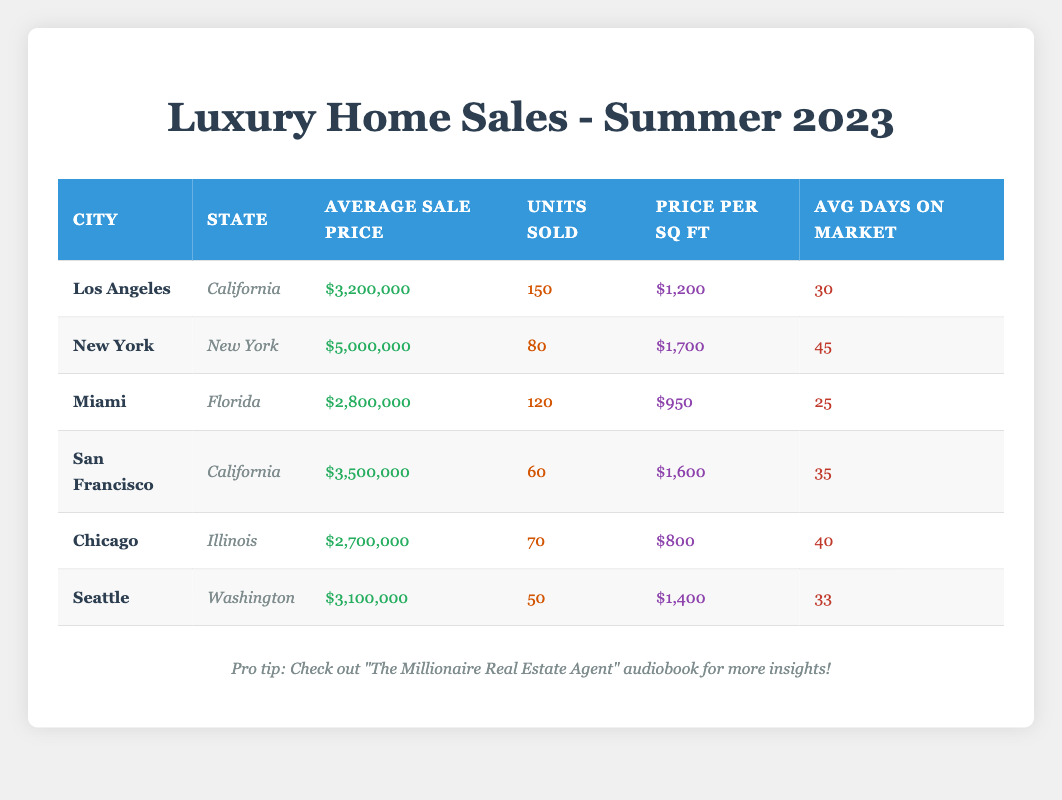What is the average sale price of luxury homes in Miami? The average sale price for luxury homes in Miami is listed in the table as $2,800,000.
Answer: $2,800,000 Which city has the highest average sale price? According to the table, New York has the highest average sale price at $5,000,000.
Answer: New York How many units of luxury homes were sold in Los Angeles? The table states that 150 units of luxury homes were sold in Los Angeles.
Answer: 150 What is the average price per square foot for luxury homes in San Francisco? The average price per square foot for luxury homes in San Francisco is shown in the table as $1,600.
Answer: $1,600 Is the average days on market for luxury homes in Chicago higher than that of Seattle? The table indicates that Chicago's average days on market is 40, while Seattle's is 33. Therefore, yes, Chicago's is higher.
Answer: Yes What is the total number of luxury homes sold across all cities listed? To find the total, we sum the units sold from each city: 150 + 80 + 120 + 60 + 70 + 50 = 630.
Answer: 630 What is the difference in average sale price between New York and Chicago? The average sale price in New York is $5,000,000, and in Chicago, it is $2,700,000. The difference is $5,000,000 - $2,700,000 = $2,300,000.
Answer: $2,300,000 Which city has a lower price per square foot, Miami or Chicago? The table shows Miami has a price per square foot of $950, while Chicago has $800. Since $950 > $800, Chicago has the lower price per square foot.
Answer: Chicago By what percentage is the average sale price in Seattle higher than in Miami? The average sale price in Seattle is $3,100,000, and in Miami, it is $2,800,000. The difference is $3,100,000 - $2,800,000 = $300,000. To find the percentage difference: ($300,000 / $2,800,000) * 100 = 10.71%.
Answer: 10.71% 